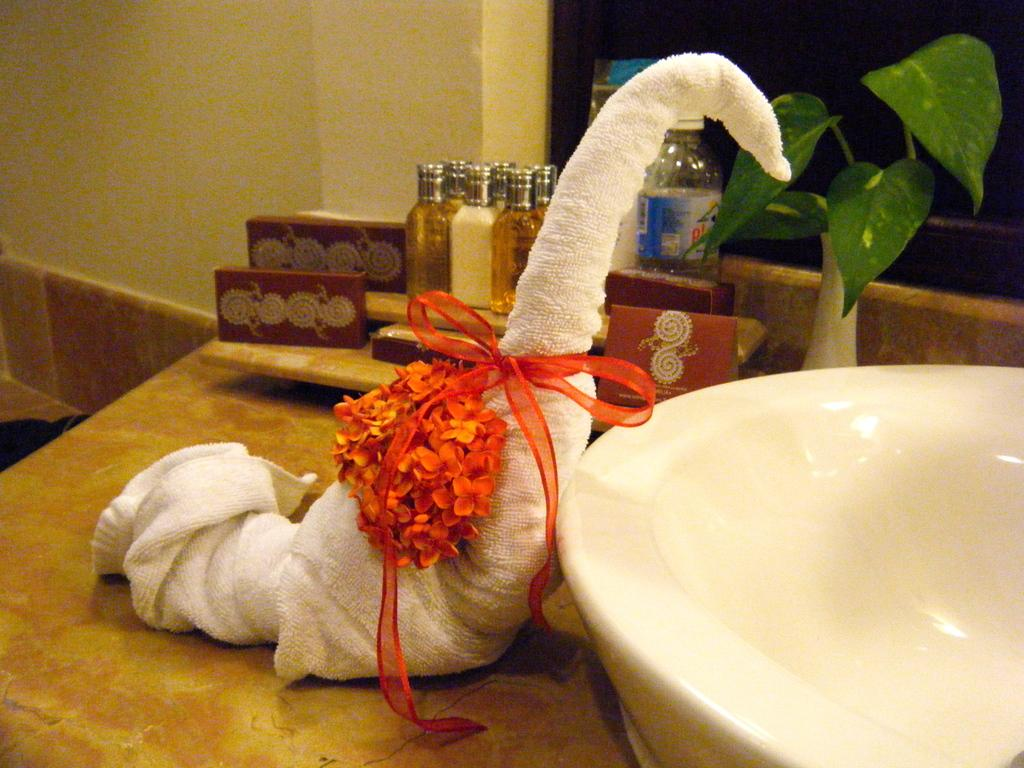What is the towel shaped like in the image? The towel is shaped like a bird in the image. How is the towel decorated or accessorized? The towel has a ribbon tied around it. What is placed on the towel? Flowers are placed on the towel. What can be seen on the right side of the image? There is a wash basin on the right side of the image. What type of plant is present in the image? There is a money plant in the image. What type of coil is visible in the image? There is no coil visible in the image. What type of tree can be seen in the image? There is no tree present in the image. 